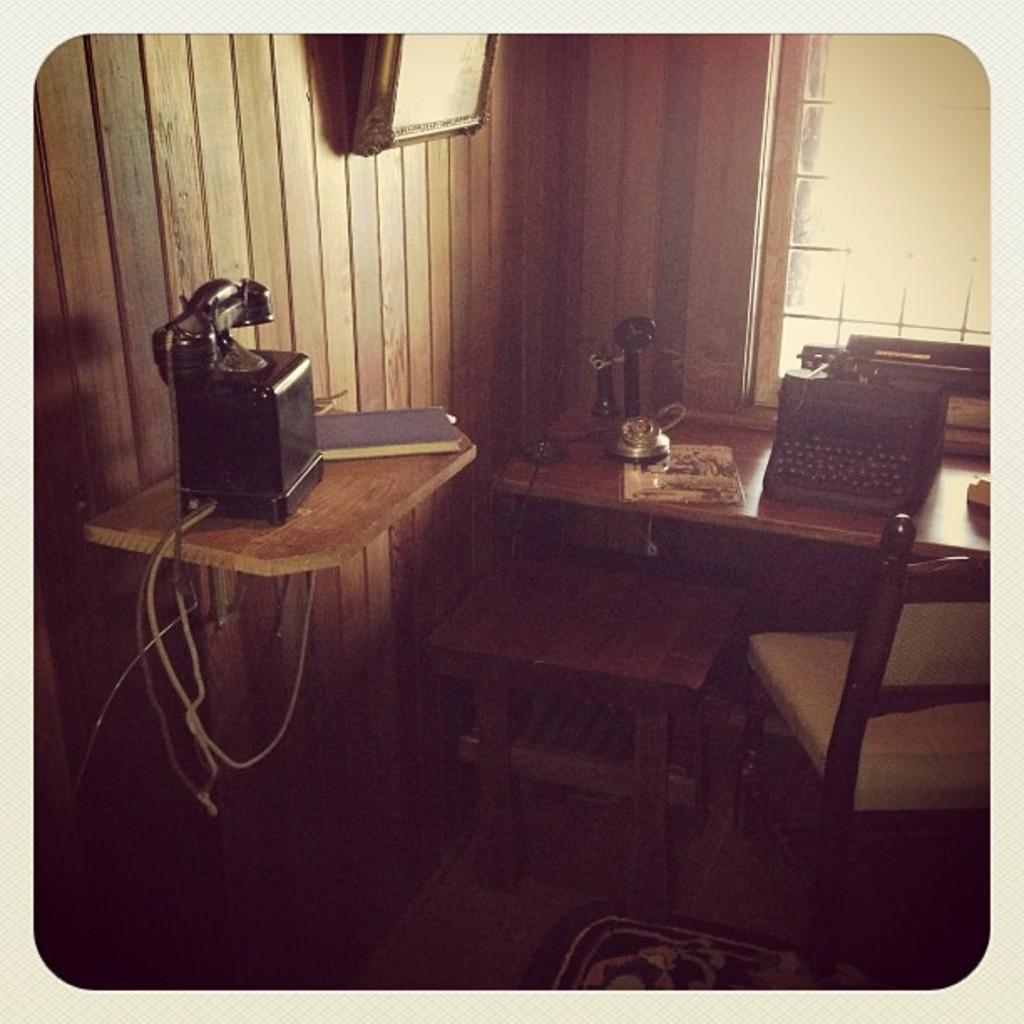How would you summarize this image in a sentence or two? In the picture I can see a typing machine and some other objects on tables. I can also see a chair, wooden wall which has some object attached to it and some other objects. 